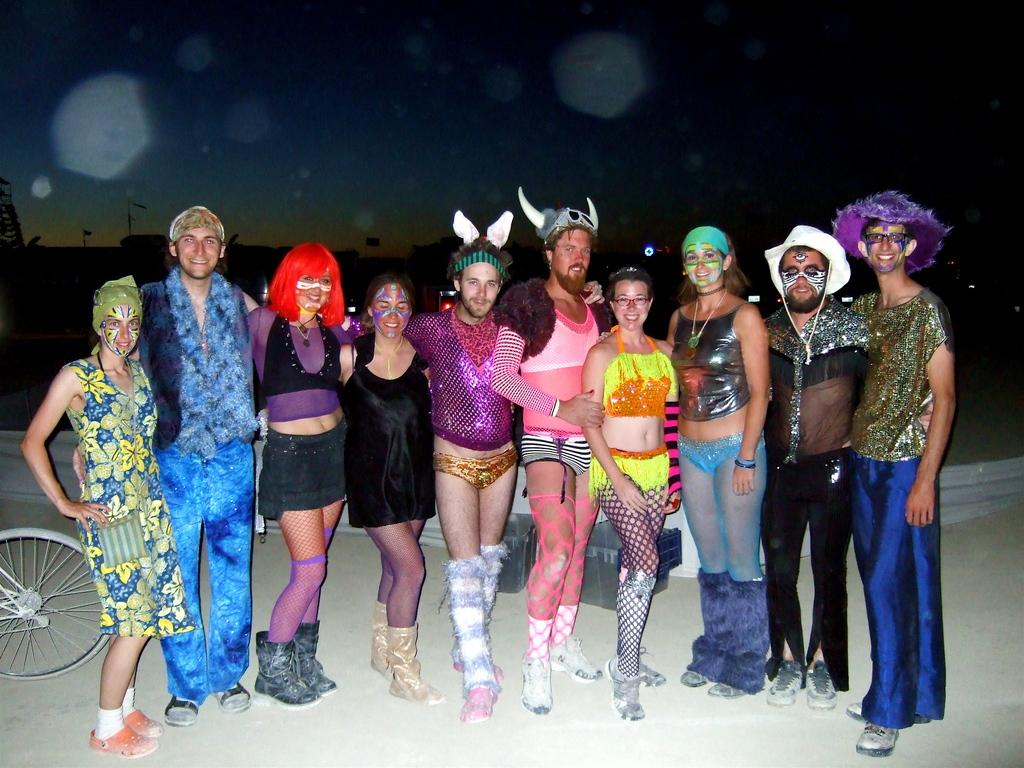How many people are in the image? There is a group of people in the image. What are the people doing in the image? The people are standing on the ground. What are the people wearing in the image? The people are wearing different costumes. What can be seen in the background of the image? There is a bicycle and the sky visible in the background of the image. How many rabbits are hopping around the people in the image? There are no rabbits present in the image. What color is the balloon that the people are holding in the image? There is no balloon present in the image. 